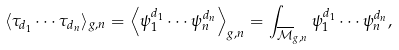Convert formula to latex. <formula><loc_0><loc_0><loc_500><loc_500>\langle \tau _ { d _ { 1 } } \cdots \tau _ { d _ { n } } \rangle _ { g , n } = \left \langle \psi _ { 1 } ^ { d _ { 1 } } \cdots \psi _ { n } ^ { d _ { n } } \right \rangle _ { g , n } = \int _ { \overline { \mathcal { M } } _ { g , n } } \psi _ { 1 } ^ { d _ { 1 } } \cdots \psi _ { n } ^ { d _ { n } } ,</formula> 